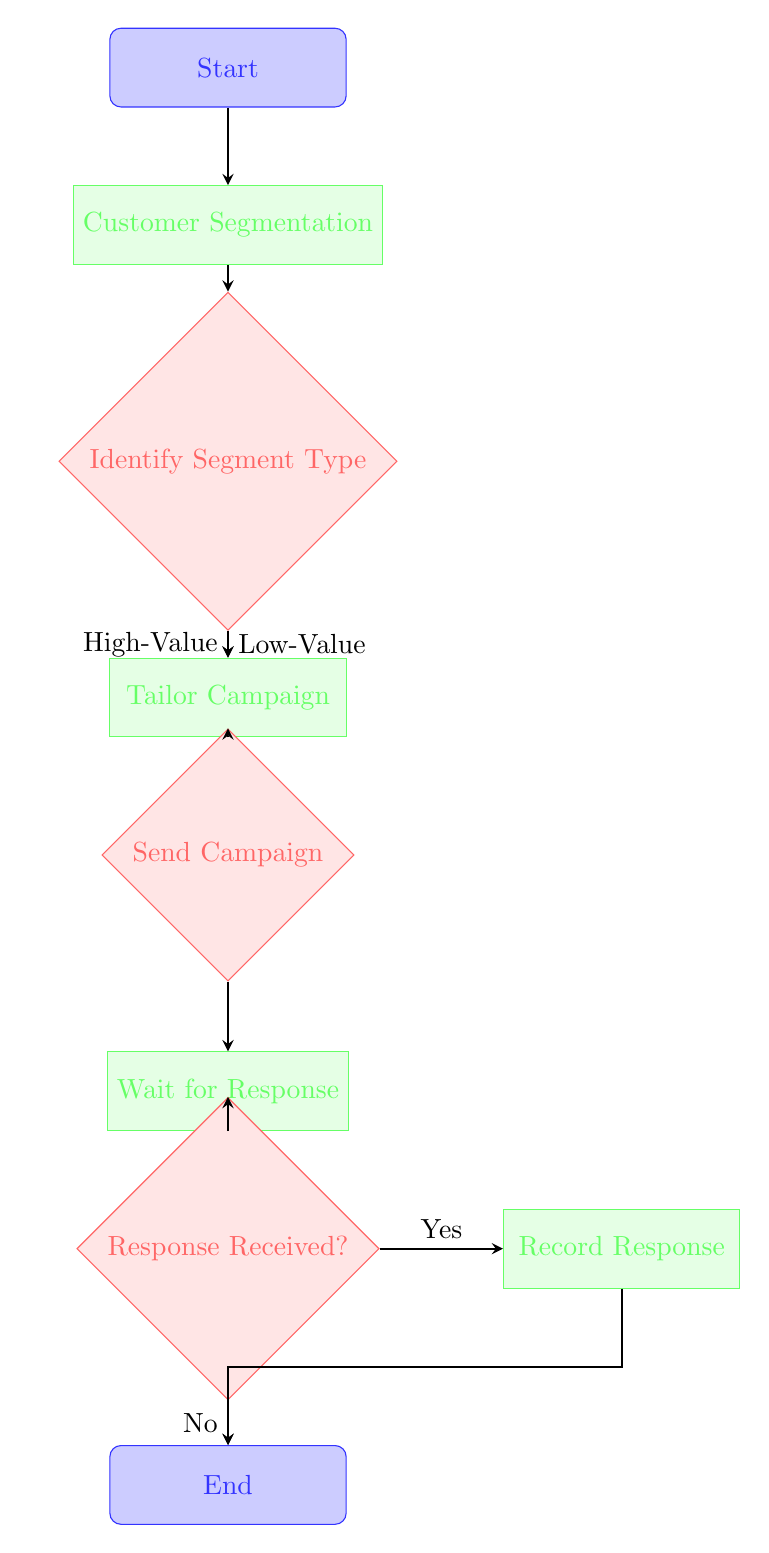What is the first node in the flow chart? The first node in the flow chart is labeled "Start". This is the initial point from which the entire process begins, leading to subsequent actions and decisions.
Answer: Start How many decision nodes are there in the flow chart? There are three decision nodes in the flow chart: "Identify Segment Type", "Send Campaign", and "Response Received?". Each of these nodes requires a yes/no decision to move forward in the process.
Answer: 3 Which process follows "Tailor Campaign"? The process that follows "Tailor Campaign" is "Send Campaign". This indicates the flow of the process after creating personalized content to actually sending out the campaign to customers.
Answer: Send Campaign What happens if the response is not received? If the response is not received, the flow chart indicates it leads directly to the "End" node. This means there are no further actions to take if no response is collected from the campaign.
Answer: End What is the condition for proceeding from "Identify Segment Type" to "Tailor Campaign"? The conditions for proceeding from "Identify Segment Type" to "Tailor Campaign" are "High-Value" and "Low-Value". Both conditions lead to the same subsequent process, indicating tailored campaigns for both segments.
Answer: High-Value, Low-Value What process captures customer responses? The process that captures customer responses is "Record Response". This step is vital for tracking how the customers interacted with the campaign that was sent out.
Answer: Record Response From which node does the flow chart begin? The flow chart begins at the node labeled "Start", which is the entry point that instigates the subsequent processes and decisions related to customer journey mapping for campaign response.
Answer: Start What node follows "Wait for Response"? The node that follows "Wait for Response" is "Response Received?". This transition indicates that after waiting, a check is made to determine if any responses have been received from the customers.
Answer: Response Received? What two paths can lead to the "End" node? The two paths that can lead to the "End" node are from "Response Received?" with the condition "No" and from "Record Response". Both paths ultimately conclude the flow of the process indicating an exit point from the chart.
Answer: No, Record Response 